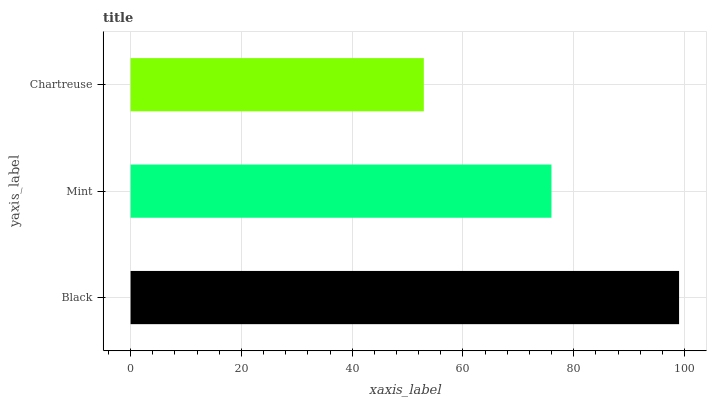Is Chartreuse the minimum?
Answer yes or no. Yes. Is Black the maximum?
Answer yes or no. Yes. Is Mint the minimum?
Answer yes or no. No. Is Mint the maximum?
Answer yes or no. No. Is Black greater than Mint?
Answer yes or no. Yes. Is Mint less than Black?
Answer yes or no. Yes. Is Mint greater than Black?
Answer yes or no. No. Is Black less than Mint?
Answer yes or no. No. Is Mint the high median?
Answer yes or no. Yes. Is Mint the low median?
Answer yes or no. Yes. Is Chartreuse the high median?
Answer yes or no. No. Is Chartreuse the low median?
Answer yes or no. No. 